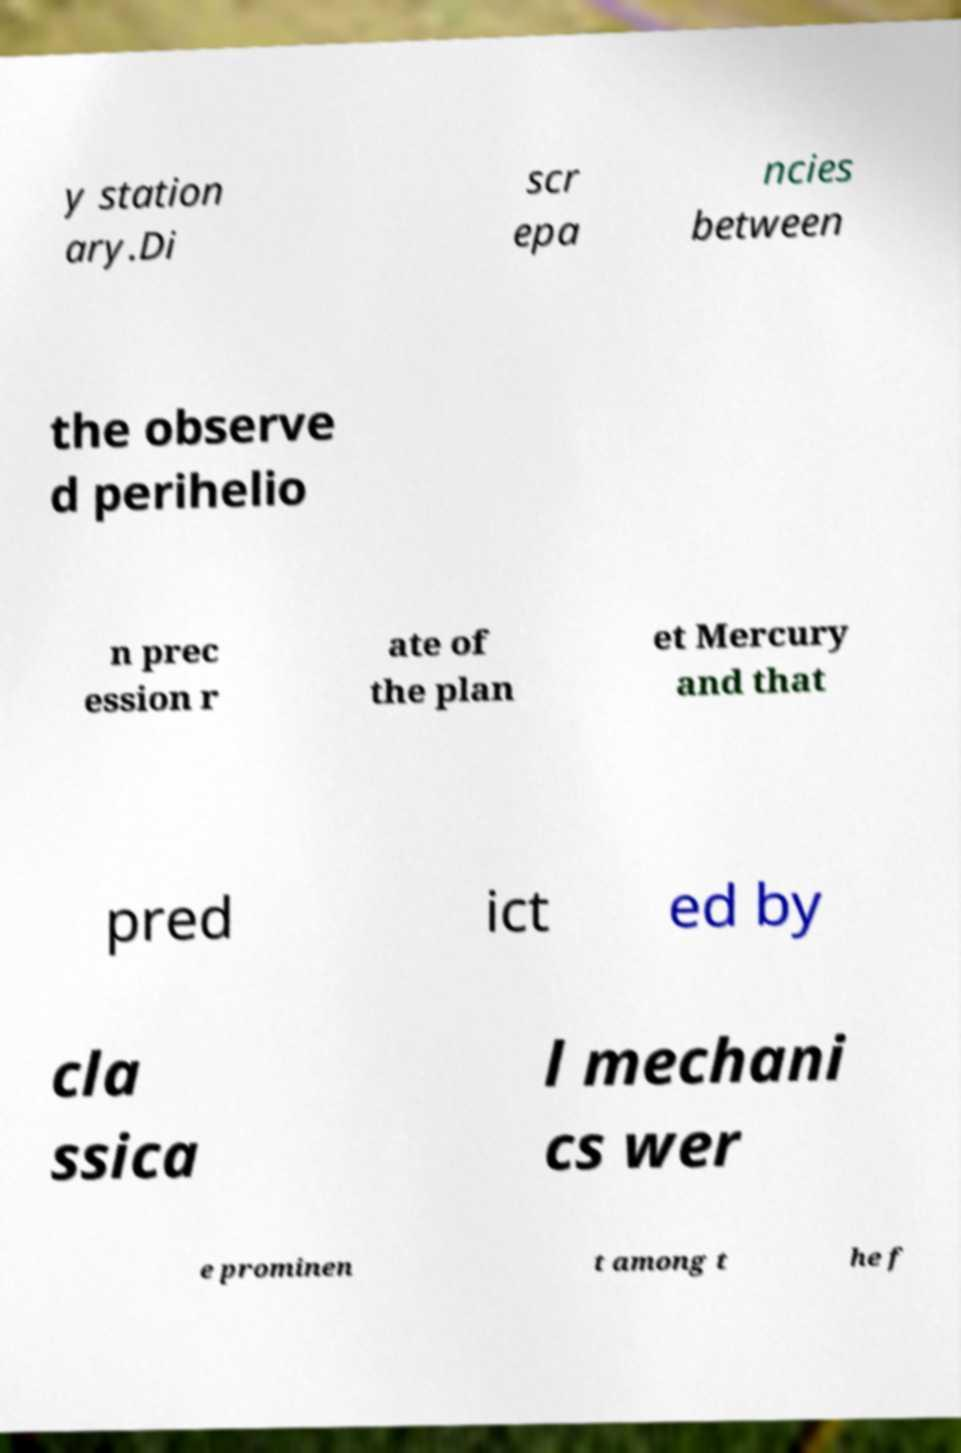Could you assist in decoding the text presented in this image and type it out clearly? y station ary.Di scr epa ncies between the observe d perihelio n prec ession r ate of the plan et Mercury and that pred ict ed by cla ssica l mechani cs wer e prominen t among t he f 